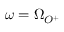<formula> <loc_0><loc_0><loc_500><loc_500>\omega = \Omega _ { O ^ { + } }</formula> 